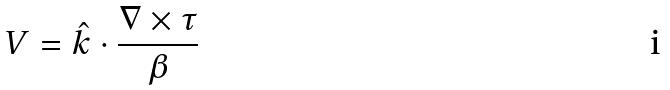Convert formula to latex. <formula><loc_0><loc_0><loc_500><loc_500>V = \hat { k } \cdot \frac { \nabla \times \tau } { \beta }</formula> 